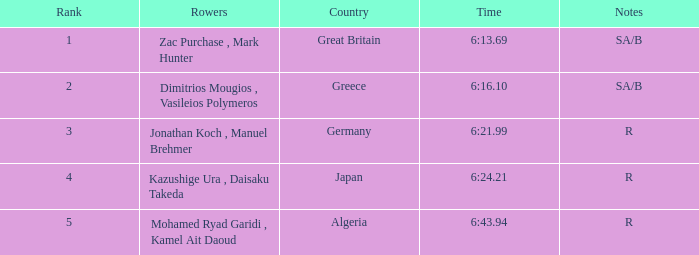What state holds the #2 ranking? Greece. 